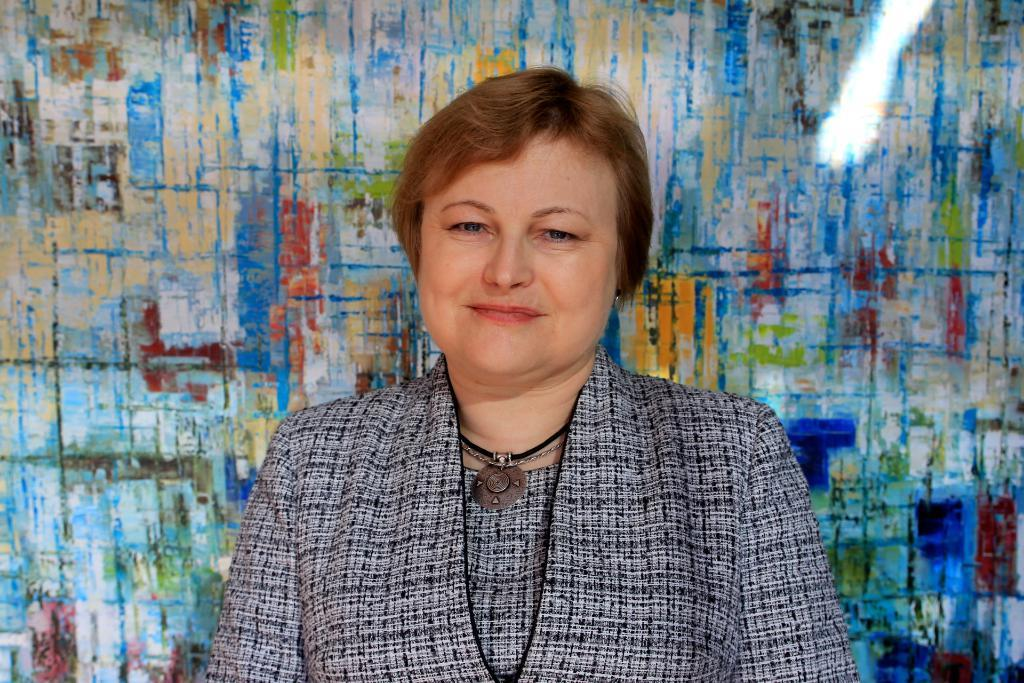Who is present in the image? There is a woman in the image. What is the woman wearing? The woman is wearing a grey dress. What can be seen behind the woman in the image? The woman is standing in front of a colorful wall. What type of bird is perched on the woman's elbow in the image? There is no bird present in the image, and the woman's elbow is not visible. 